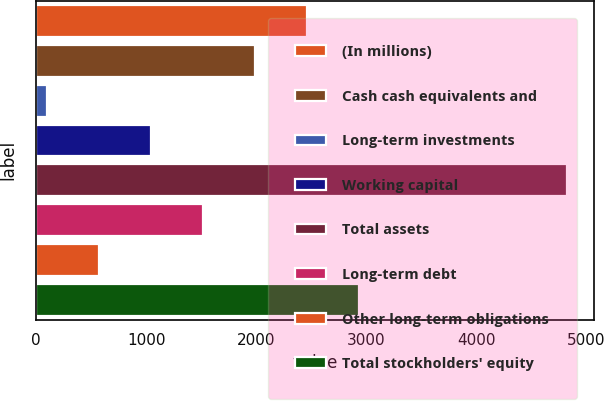<chart> <loc_0><loc_0><loc_500><loc_500><bar_chart><fcel>(In millions)<fcel>Cash cash equivalents and<fcel>Long-term investments<fcel>Working capital<fcel>Total assets<fcel>Long-term debt<fcel>Other long-term obligations<fcel>Total stockholders' equity<nl><fcel>2461.5<fcel>1988.6<fcel>97<fcel>1042.8<fcel>4826<fcel>1515.7<fcel>569.9<fcel>2934.4<nl></chart> 